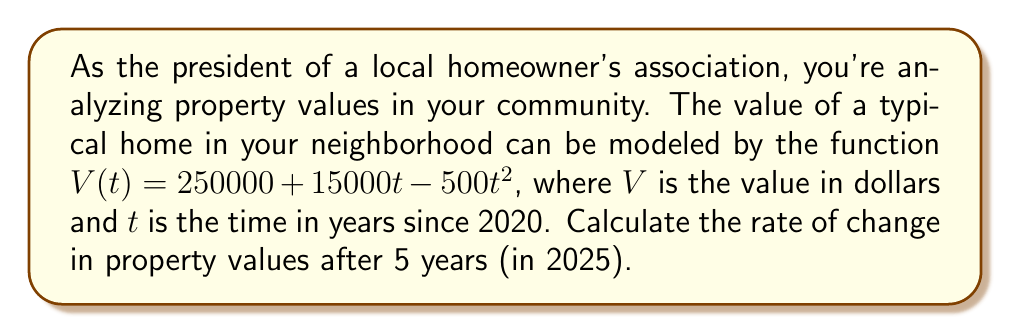Teach me how to tackle this problem. To find the rate of change in property values after 5 years, we need to calculate the derivative of the given function and evaluate it at $t = 5$.

1. Given function: $V(t) = 250000 + 15000t - 500t^2$

2. Calculate the derivative:
   $$\frac{dV}{dt} = 15000 - 1000t$$

3. Evaluate the derivative at $t = 5$:
   $$\frac{dV}{dt}\Big|_{t=5} = 15000 - 1000(5)$$
   $$= 15000 - 5000$$
   $$= 10000$$

4. Interpret the result:
   The rate of change in property values after 5 years (in 2025) is $10000 per year.
Answer: $10000 per year 